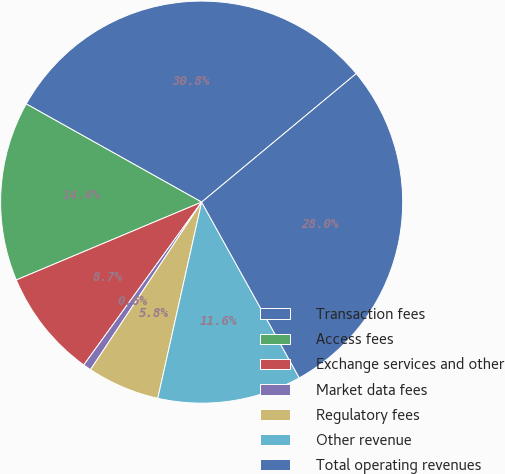Convert chart to OTSL. <chart><loc_0><loc_0><loc_500><loc_500><pie_chart><fcel>Transaction fees<fcel>Access fees<fcel>Exchange services and other<fcel>Market data fees<fcel>Regulatory fees<fcel>Other revenue<fcel>Total operating revenues<nl><fcel>30.84%<fcel>14.45%<fcel>8.7%<fcel>0.65%<fcel>5.82%<fcel>11.57%<fcel>27.97%<nl></chart> 